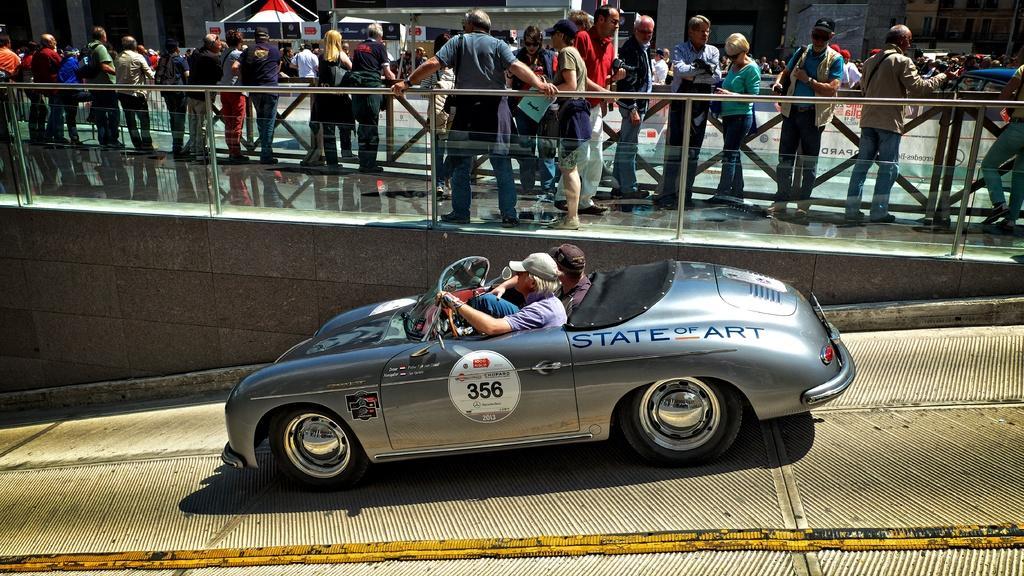In one or two sentences, can you explain what this image depicts? In this picture we can see two men sitting inside a car and riding. We can see all the persons standing busy with their own works on the bridge. 